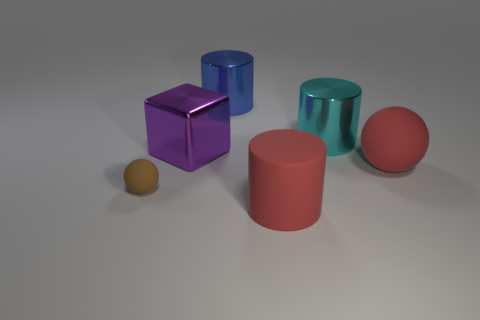Add 2 big blue things. How many objects exist? 8 Subtract all cubes. How many objects are left? 5 Subtract 0 blue blocks. How many objects are left? 6 Subtract all large purple things. Subtract all brown rubber things. How many objects are left? 4 Add 2 big blue shiny cylinders. How many big blue shiny cylinders are left? 3 Add 2 tiny gray metallic blocks. How many tiny gray metallic blocks exist? 2 